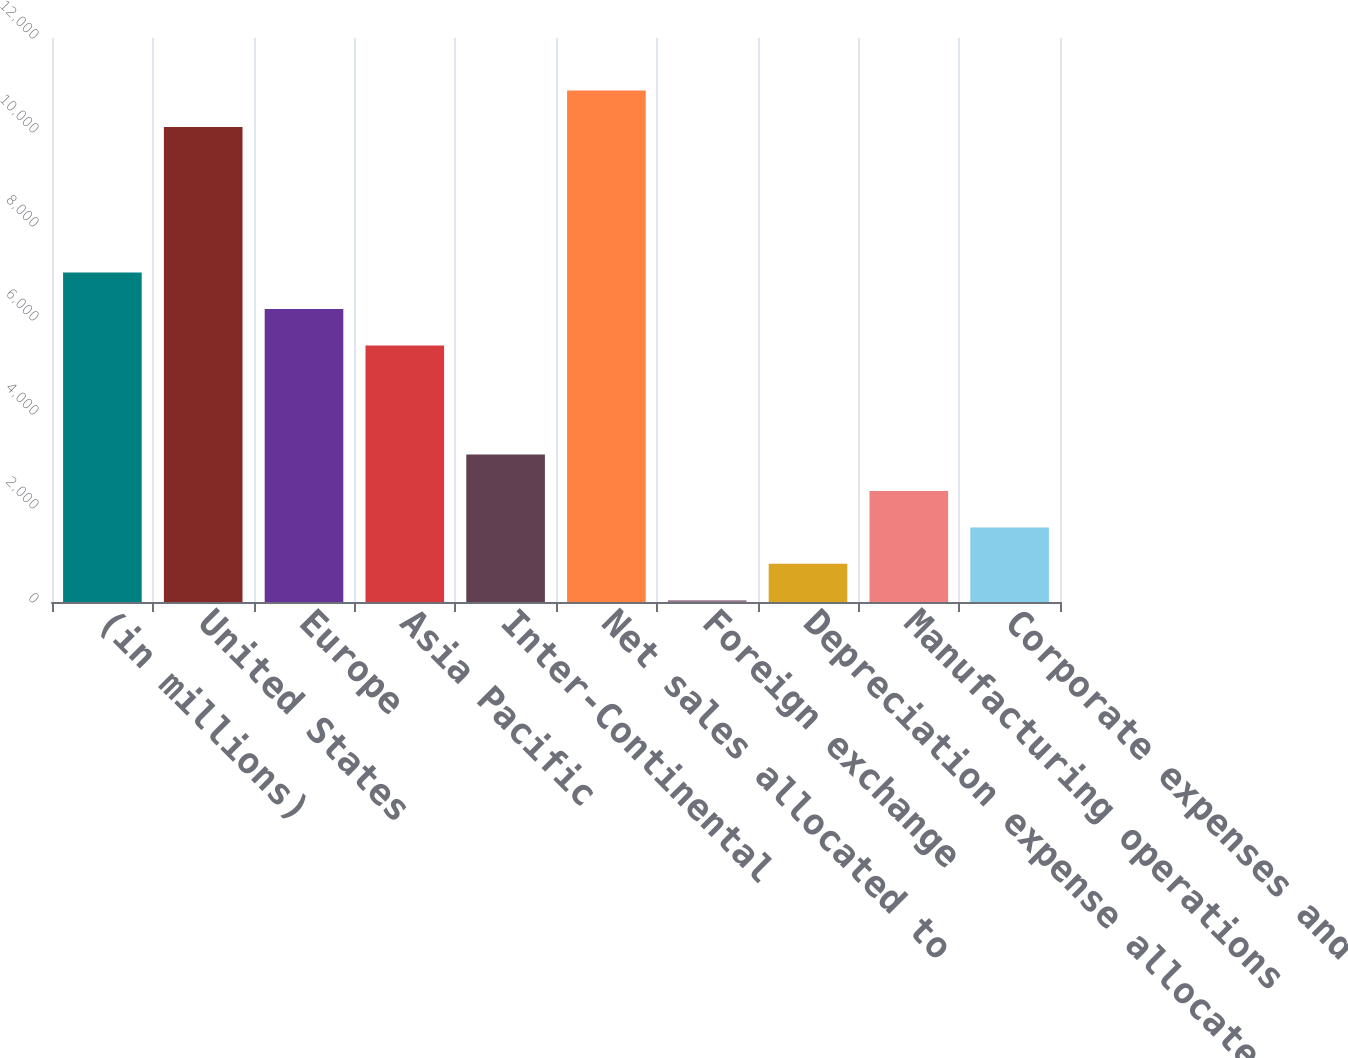<chart> <loc_0><loc_0><loc_500><loc_500><bar_chart><fcel>(in millions)<fcel>United States<fcel>Europe<fcel>Asia Pacific<fcel>Inter-Continental<fcel>Net sales allocated to<fcel>Foreign exchange<fcel>Depreciation expense allocated<fcel>Manufacturing operations<fcel>Corporate expenses and foreign<nl><fcel>7008.5<fcel>10106.5<fcel>6234<fcel>5459.5<fcel>3136<fcel>10881<fcel>38<fcel>812.5<fcel>2361.5<fcel>1587<nl></chart> 